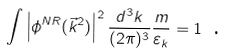<formula> <loc_0><loc_0><loc_500><loc_500>\int \left | \phi ^ { N R } ( \vec { k } ^ { 2 } ) \right | ^ { 2 } \frac { d ^ { 3 } k } { ( 2 \pi ) ^ { 3 } } \frac { m } { \varepsilon _ { k } } = 1 \text { .}</formula> 